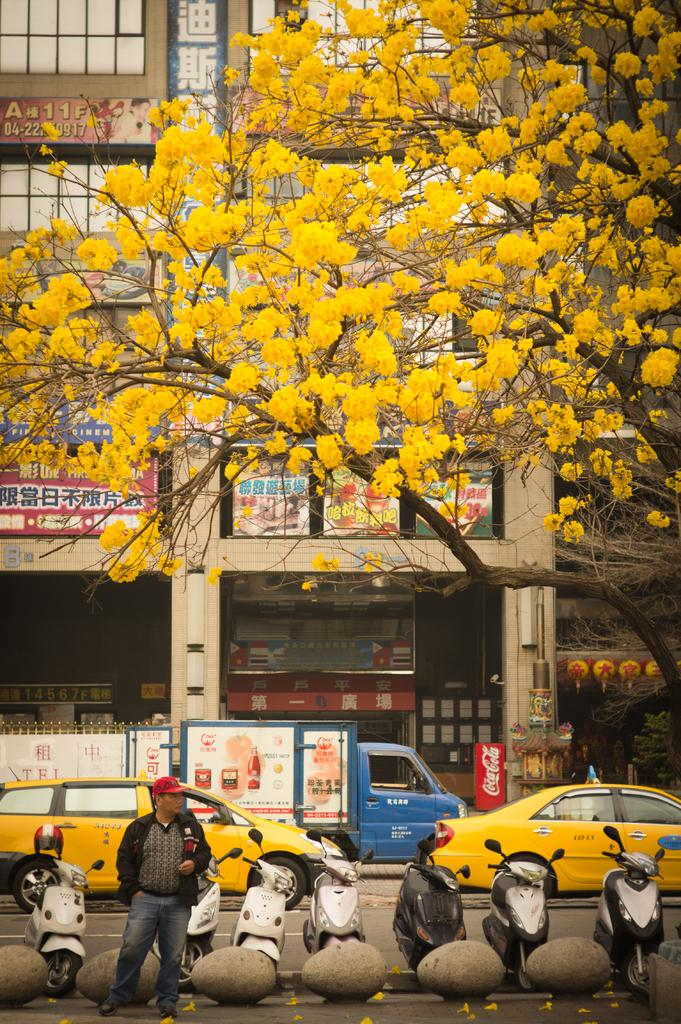<image>
Describe the image concisely. A man stands in front of a row of scooters with yellow taxis and a Coca Cola vending machine in the background. 